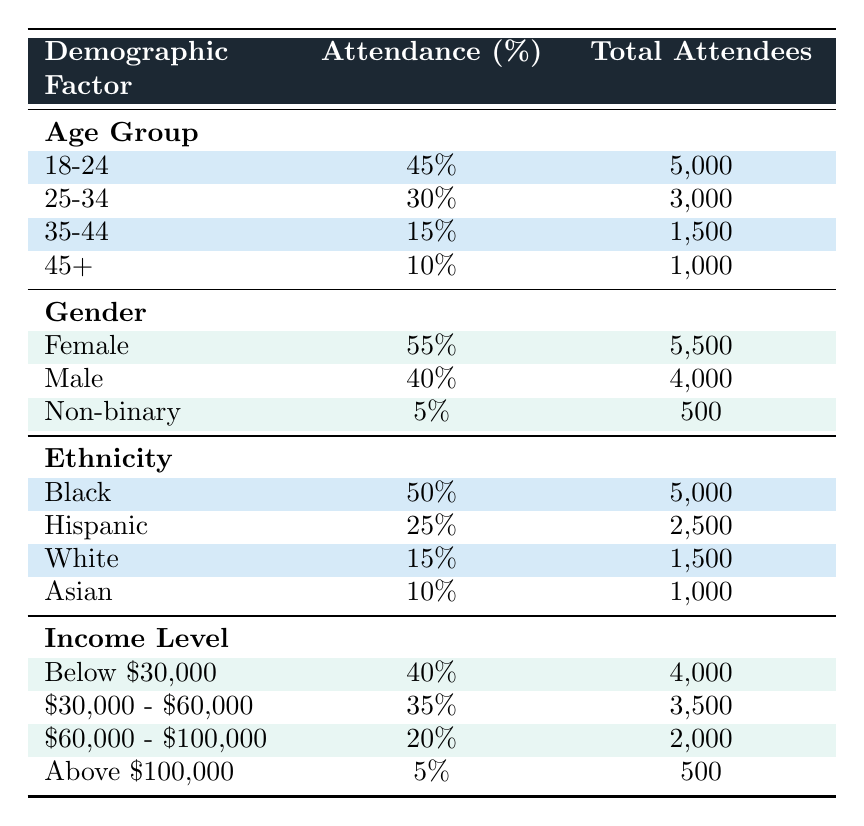What percentage of attendees are aged 25-34? The table lists the attendance percentage for the age group 25-34, which is directly provided as 30%.
Answer: 30% How many total attendees are male? The table shows that the total number of male attendees is explicitly listed as 4000.
Answer: 4000 Which demographic group has the highest attendance percentage? The highest attendance percentage is found in the Gender category, where Female has 55%, which is higher than any other group listed in the Age Group, Ethnicity, or Income Level categories.
Answer: Female What is the combined percentage of attendees from the age groups 35-44 and 45+? To answer this, we simply add the percentages of the age groups 35-44 (15%) and 45+ (10%). The sum is 15% + 10% = 25%.
Answer: 25% Is the total number of attendees with an income of above $100,000 more than the attendees aged 45 and above? The total number of attendees with an income above $100,000 is 500, while for the age group 45+, the total attendees is 1000. Since 500 is less than 1000, the answer is no.
Answer: No What percentage of total concert attendees were Black? According to the Ethnicity section of the table, Black attendees accounted for 50% of total attendees.
Answer: 50% If we combine the total attendees from both the 18-24 and 25-34 age groups, what is that total? The total number of attendees in the age groups can be found by adding the total attendees from 18-24 (5000) and 25-34 (3000), resulting in 5000 + 3000 = 8000.
Answer: 8000 Which gender has the lowest attendance percentage? The Female gender has the highest at 55%, followed by Male at 40%, and Non-binary has the lowest attendance percentage of 5%.
Answer: Non-binary What is the average percentage attendance across all income levels? To calculate the average attendance percentage across income levels, add the attendance percentages: 40% + 35% + 20% + 5% = 100%. There are 4 groups, so the average is 100% / 4 = 25%.
Answer: 25% 